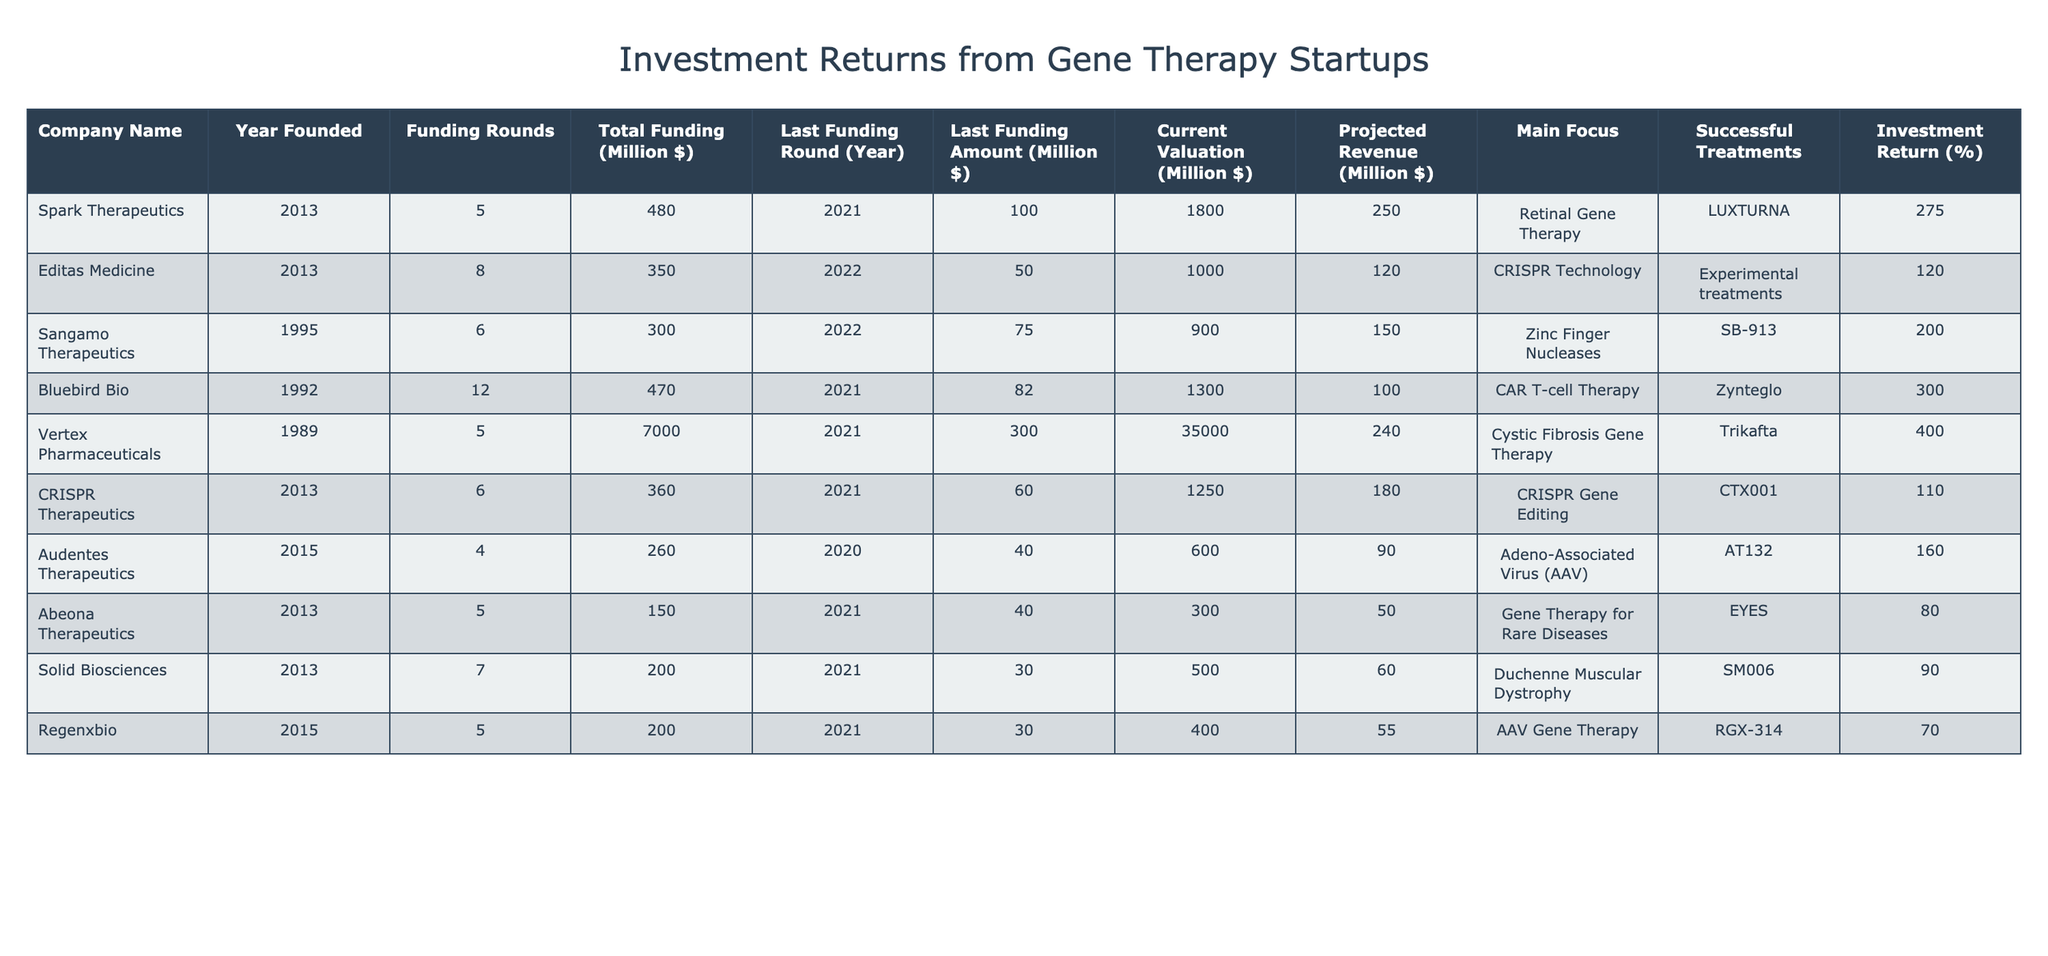What is the Current Valuation of Spark Therapeutics? The table lists Current Valuation for each company. For Spark Therapeutics, the value provided is 1800 million dollars.
Answer: 1800 million dollars Which company has the highest Investment Return? The Investment Return is listed for each company. Vertex Pharmaceuticals has the highest return at 400%.
Answer: 400% What is the Total Funding received by Editas Medicine? The Total Funding for Editas Medicine in the table is reported as 350 million dollars.
Answer: 350 million dollars Which company had its Last Funding Amount in the year 2021? The table shows that multiple companies had their last funding amount in 2021; they include Spark Therapeutics, Bluebird Bio, Vertex Pharmaceuticals, Abeona Therapeutics, Solid Biosciences, and Regenxbio.
Answer: Spark Therapeutics, Bluebird Bio, Vertex Pharmaceuticals, Abeona Therapeutics, Solid Biosciences, Regenxbio Calculate the average Projected Revenue of all companies in the table. The Projected Revenue values are 250, 120, 150, 100, 240, 180, 90, 50, 60, and 55. Summing them gives 1095. There are 10 companies, so the average is 1095/10 = 109.5 million dollars.
Answer: 109.5 million dollars Is there at least one company that focuses on CRISPR technology? By reviewing the Main Focus column, we see that both Editas Medicine and CRISPR Therapeutics focus on CRISPR Technology, confirming that the statement is true.
Answer: Yes What is the difference in Total Funding between Spark Therapeutics and Vertex Pharmaceuticals? The Total Funding for Spark Therapeutics is 480 million dollars, and for Vertex Pharmaceuticals, it is 7000 million dollars. The difference is 7000 - 480 = 6520 million dollars.
Answer: 6520 million dollars Which company has developed a successful treatment for Duchenne Muscular Dystrophy? According to the Successful Treatments column, Solid Biosciences has developed a treatment, SM006, for Duchenne Muscular Dystrophy.
Answer: Solid Biosciences What is the total number of funding rounds for companies founded in 2013? The funding rounds for companies founded in 2013 (Spark Therapeutics, Editas Medicine, CRISPR Therapeutics, and Abeona Therapeutics) are 5, 8, 6, and 5, respectively. Their sum is 5 + 8 + 6 + 5 = 24 funding rounds.
Answer: 24 funding rounds Did any company report a Projected Revenue below 100 million dollars? Reviewing the Projected Revenue column, companies like Audentes Therapeutics (90 million), Abeona Therapeutics (50 million), Solid Biosciences (60 million), and Regenxbio (55 million) all reported revenues below 100 million.
Answer: Yes Which of the listed companies has the least Total Funding? By comparing the Total Funding amounts in the table, we find that Abeona Therapeutics has the least at 150 million dollars.
Answer: 150 million dollars 